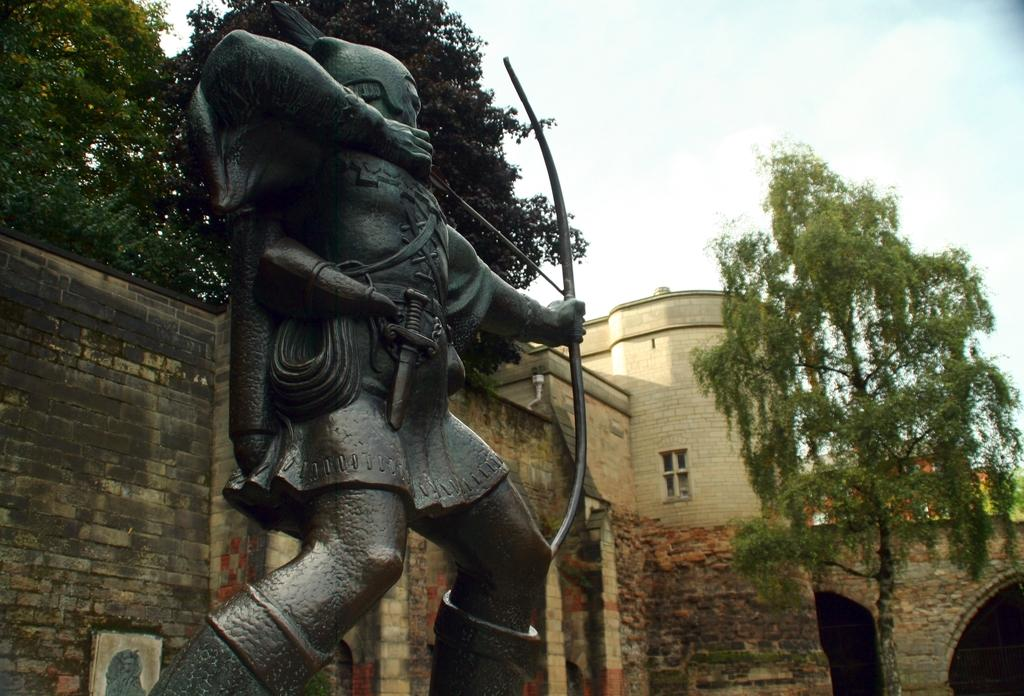What is the main subject in the center of the image? There is a statue in the center of the image. What can be seen in the background of the image? There are trees, a wall, and a window in the background of the image. What is visible at the top of the image? The sky is visible at the top of the image. Can you see a yak playing basketball in the image? No, there is no yak or basketball present in the image. 